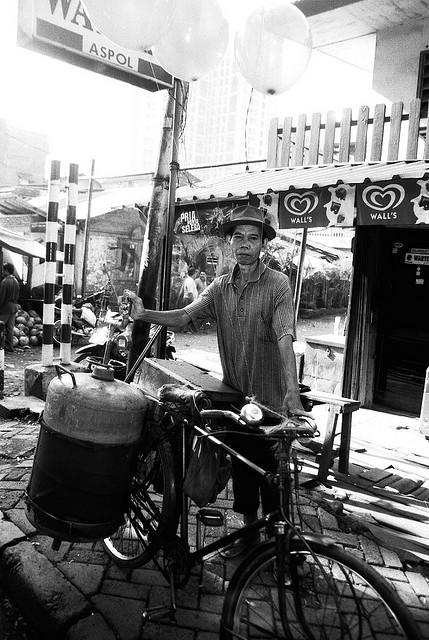What is the shape of the Wall's logo? Please explain your reasoning. heart. The logo on the wall is in the shape of a heart. 